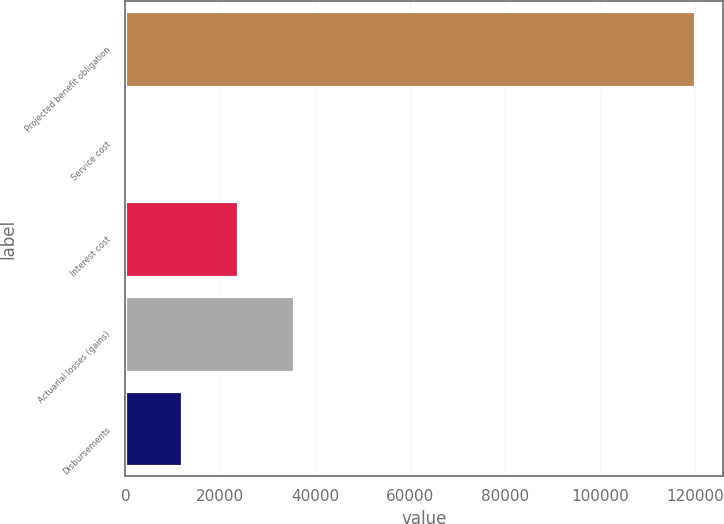Convert chart to OTSL. <chart><loc_0><loc_0><loc_500><loc_500><bar_chart><fcel>Projected benefit obligation<fcel>Service cost<fcel>Interest cost<fcel>Actuarial losses (gains)<fcel>Disbursements<nl><fcel>119958<fcel>55<fcel>23735.8<fcel>35576.2<fcel>11895.4<nl></chart> 